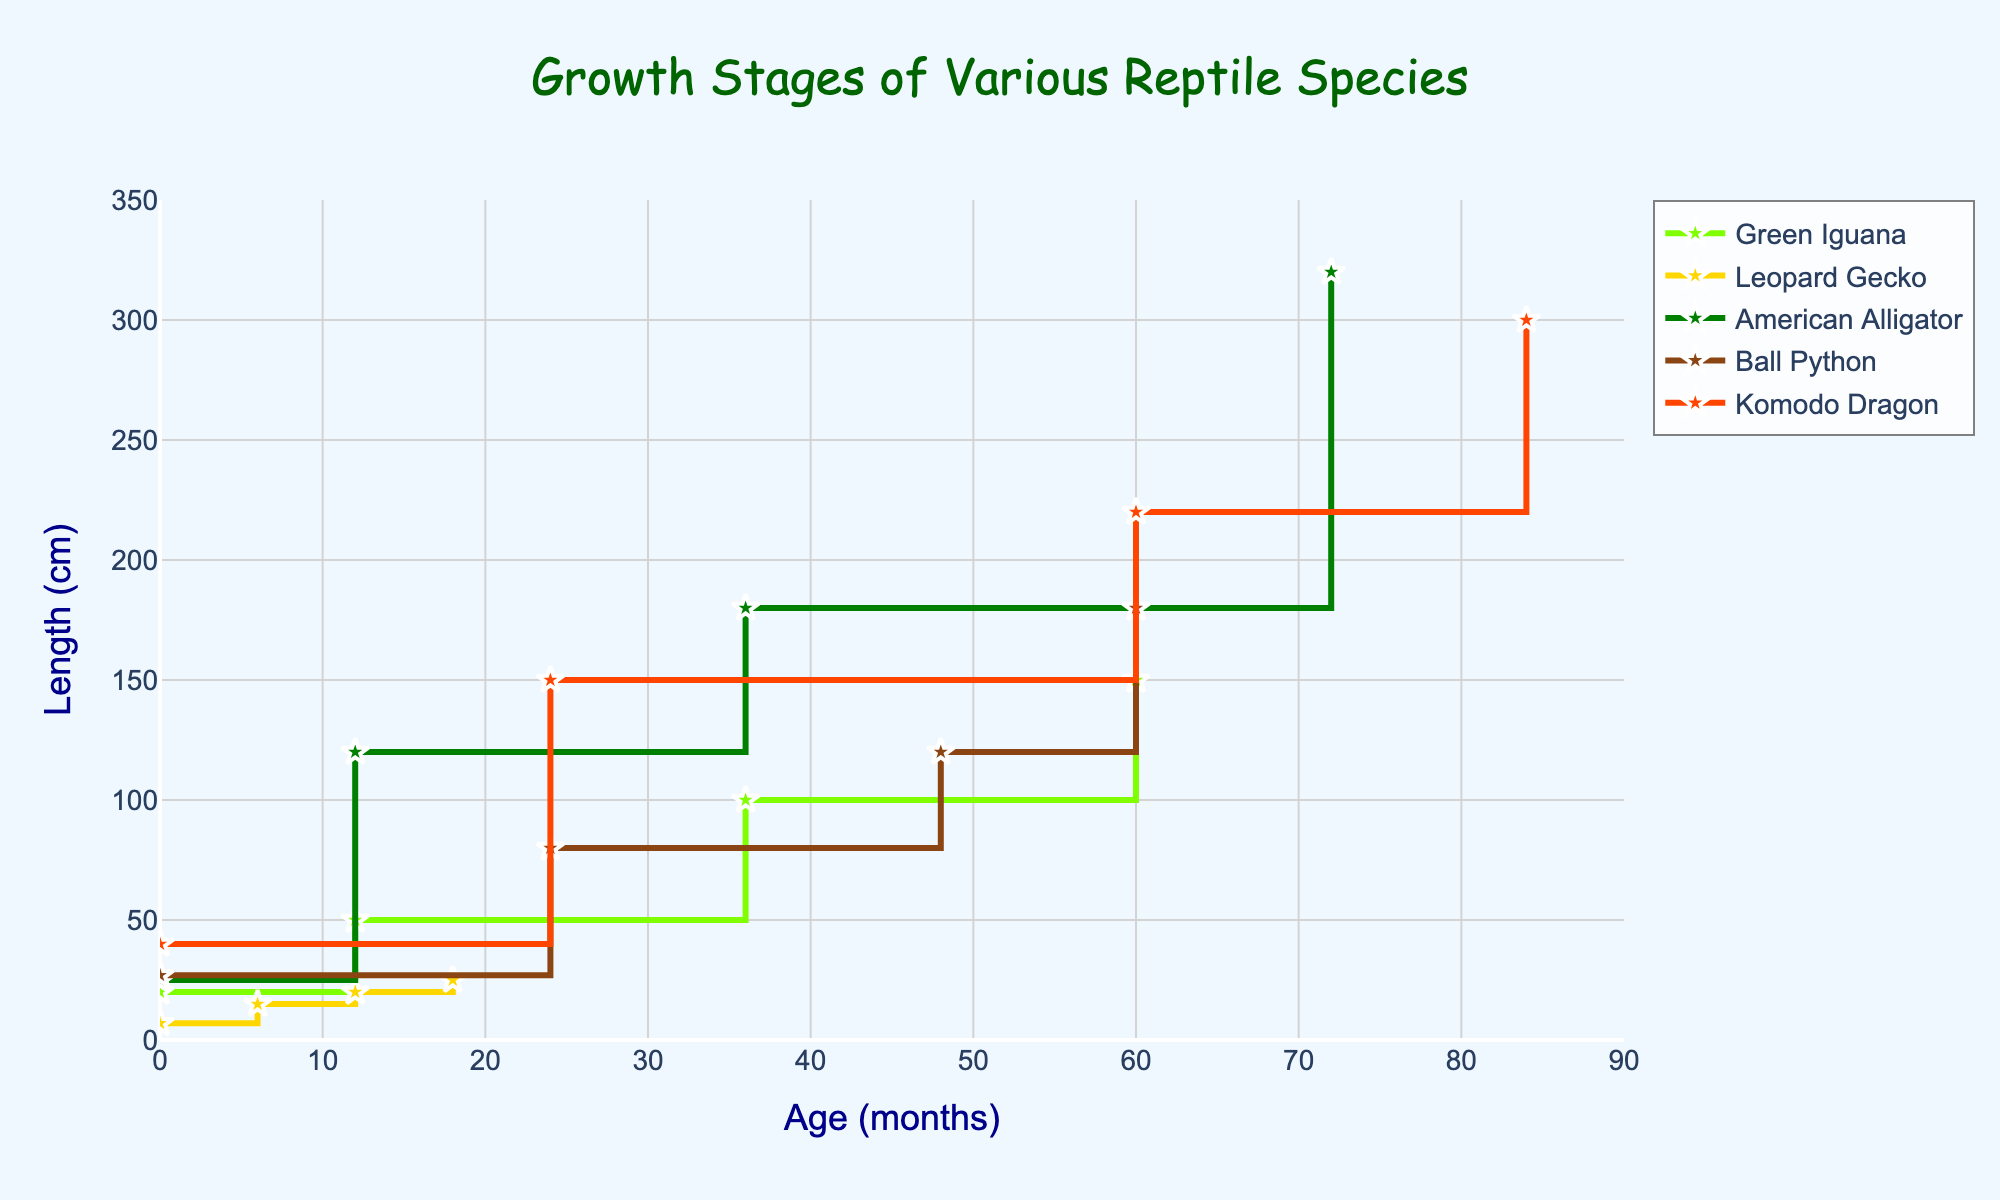What is the title of the figure? The title is displayed at the top center of the figure in a larger font size and reads "Growth Stages of Various Reptile Species."
Answer: Growth Stages of Various Reptile Species What is the average length of an adult Komodo Dragon? Locate the plot line for the Komodo Dragon and find the point labeled 'Adult'. The 'Adult' Komodo Dragon has an average length of 300 cm.
Answer: 300 cm How many growth stages are depicted for the American Alligator? Identify the labels on the plot line for the American Alligator, which are 'Hatchling', 'Juvenile', 'Sub-adult', and 'Adult'. There are 4 stages.
Answer: 4 Which species has the longest average length at the 'Hatchling' stage? Look at the Hatchling data points for all species and compare their lengths. The American Alligator has the longest average length at the Hatchling stage with 25 cm.
Answer: American Alligator At what age does the Leopard Gecko reach the 'Adult' stage? Locate the point labeled 'Adult' on the Leopard Gecko's plot line and read the corresponding age from the x-axis. The Leopard Gecko reaches the 'Adult' stage at 18 months.
Answer: 18 months Compare the growth rate between the 'Hatchling' and 'Juvenile' stages of the Green Iguana and the American Alligator. Which one grows faster and by how much? Calculate the growth rate for the Green Iguana between Hatchling (20 cm) and Juvenile (50 cm): 50 - 20 = 30 cm over 12 months. For the American Alligator between Hatchling (25 cm) and Juvenile (120 cm): 120 - 25 = 95 cm over 12 months. The American Alligator grows faster by 95 - 30 = 65 cm.
Answer: American Alligator by 65 cm What is the total length increase from Hatchling to Adult for the Ball Python? Identify the lengths of the Ball Python at 'Hatchling', which is 27 cm, and at 'Adult', which is 180 cm. Calculate the difference: 180 - 27 = 153 cm.
Answer: 153 cm Which species reaches its 'Sub-adult' stage the quickest (in the least number of months)? Observe the x-axis values for the 'Sub-adult' stage across all species. The Leopard Gecko reaches the Sub-adult stage the quickest at 12 months.
Answer: Leopard Gecko at 12 months Is there a species that reaches its 'Adult' stage at exactly 60 months? If so, which one? Check the x-axis values for the 'Adult' stage across all species. Both the Green Iguana and Ball Python reach the 'Adult' stage at 60 months.
Answer: Green Iguana and Ball Python What is the average length of the 'Juvenile' stage across all five species? List the lengths of the 'Juvenile' stage for Green Iguana (50 cm), Leopard Gecko (15 cm), American Alligator (120 cm), Ball Python (80 cm), and Komodo Dragon (150 cm). Add these and divide by 5: (50 + 15 + 120 + 80 + 150) / 5 = 415 / 5 = 83 cm.
Answer: 83 cm 